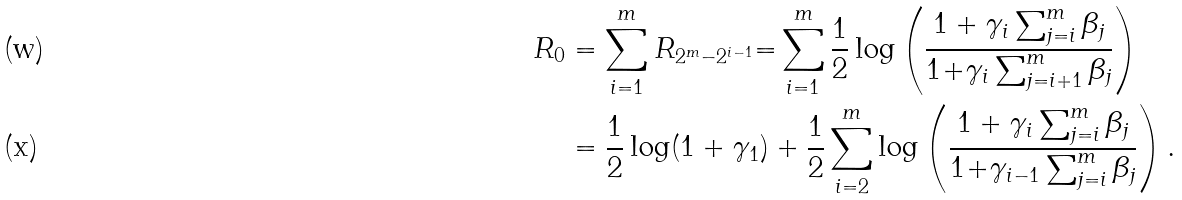Convert formula to latex. <formula><loc_0><loc_0><loc_500><loc_500>R _ { 0 } & = \sum _ { i = 1 } ^ { m } R _ { 2 ^ { m } - 2 ^ { i - 1 } } { = } \sum _ { i = 1 } ^ { m } \frac { 1 } { 2 } \log \left ( \frac { 1 + \gamma _ { i } \sum _ { j = i } ^ { m } \beta _ { j } } { 1 { + } \gamma _ { i } \sum _ { j = i + 1 } ^ { m } \beta _ { j } } \right ) \\ & = \frac { 1 } { 2 } \log ( 1 + \gamma _ { 1 } ) + \frac { 1 } { 2 } \sum _ { i = 2 } ^ { m } \log \left ( \frac { 1 + \gamma _ { i } \sum _ { j = i } ^ { m } \beta _ { j } } { 1 { + } \gamma _ { i - 1 } \sum _ { j = i } ^ { m } \beta _ { j } } \right ) .</formula> 